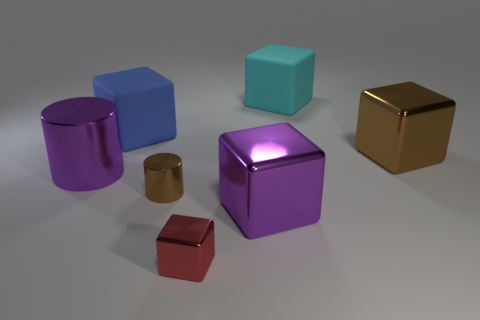What color is the tiny object that is the same shape as the big cyan object?
Your response must be concise. Red. Do the rubber cube left of the red metal block and the purple shiny block have the same size?
Your answer should be compact. Yes. There is a metal cylinder that is behind the cylinder right of the large cylinder; what size is it?
Give a very brief answer. Large. Does the large cyan block have the same material as the purple object that is in front of the big purple metal cylinder?
Give a very brief answer. No. Is the number of cylinders right of the big cyan rubber cube less than the number of cyan blocks that are in front of the purple metal cylinder?
Offer a very short reply. No. There is a large block that is the same material as the big brown thing; what is its color?
Give a very brief answer. Purple. Are there any brown cylinders that are in front of the purple shiny thing in front of the brown shiny cylinder?
Your answer should be very brief. No. What color is the metallic object that is the same size as the brown cylinder?
Your answer should be compact. Red. How many things are big blue matte objects or small purple metal things?
Provide a succinct answer. 1. There is a purple object to the left of the tiny metal object that is in front of the big metallic cube that is in front of the big brown block; what size is it?
Provide a short and direct response. Large. 